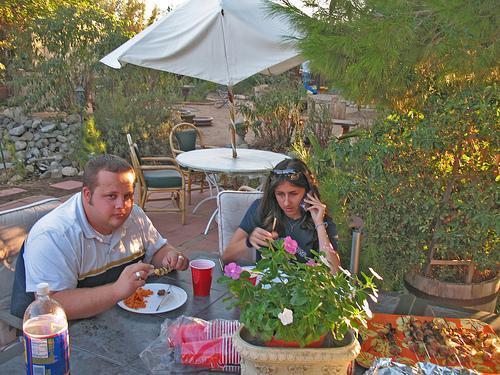How many people on are their phones?
Give a very brief answer. 1. 